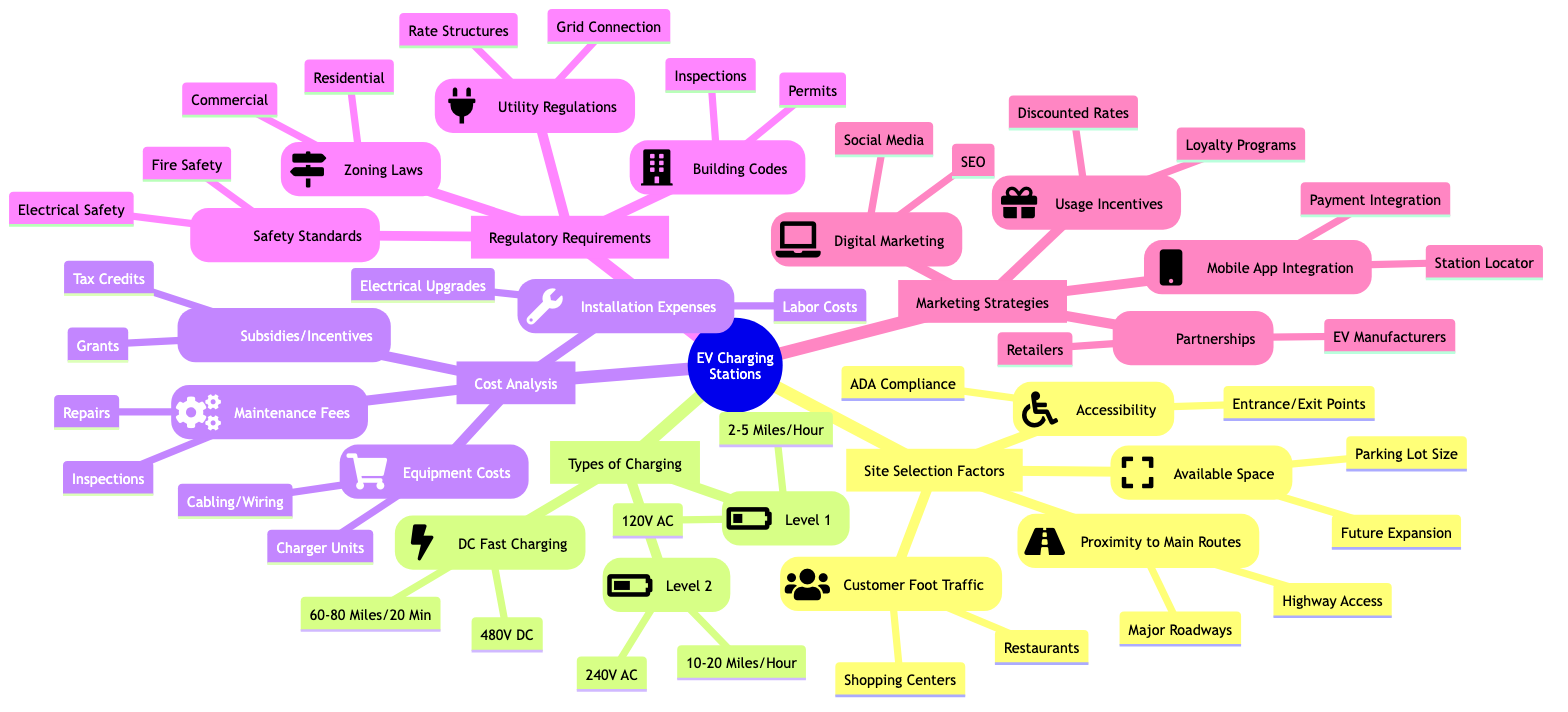What are the four factors listed under Site Selection? The diagram lists Proximity to Main Traffic Routes, Accessibility, Available Space, and Potential Customer Foot Traffic as the four factors under Site Selection.
Answer: Proximity to Main Traffic Routes, Accessibility, Available Space, Potential Customer Foot Traffic How many types of EV Charging Stations are mentioned? The diagram specifies three types of EV Charging Stations: Level 1, Level 2, and DC Fast Charging.
Answer: Three What are the equipment costs associated with EV Charging Stations? Under Cost Analysis, the Equipment Costs node includes Charger Unit Prices and Cabling and Wiring Costs as the key elements.
Answer: Charger Unit Prices, Cabling and Wiring Costs What incentive types are listed under Potential Subsidies or Incentives? The diagram lists Federal Tax Credits, State Grants, and Utility Company Rebates under Potential Subsidies or Incentives.
Answer: Federal Tax Credits, State Grants, Utility Company Rebates How do Level 2 and DC Fast Charging differ in power output? The Level 2 charging provides 10-20 miles of range per hour while DC Fast Charging offers 60-80 miles of range in 20 minutes, indicating a significant difference in efficiency.
Answer: 10-20 miles per hour for Level 2 and 60-80 miles in 20 minutes for DC Fast Charging What safety standards are required for installing EV Charging Stations? The safety standards listed in the diagram include Electrical Safety Standards and Fire Safety Regulations which must be adhered to according to Regulatory Requirements.
Answer: Electrical Safety Standards, Fire Safety Regulations Which marketing strategy includes Social Media Campaigns? The Digital Marketing node encompasses Social Media Campaigns, which is one of the strategies listed for promoting EV Charging Stations.
Answer: Digital Marketing What is required under Local Building Codes for EV Charging Station installation? The Local Building Codes section requires Permit Requirements and Inspection Processes, indicating compliance requirements for installation.
Answer: Permit Requirements, Inspection Processes 